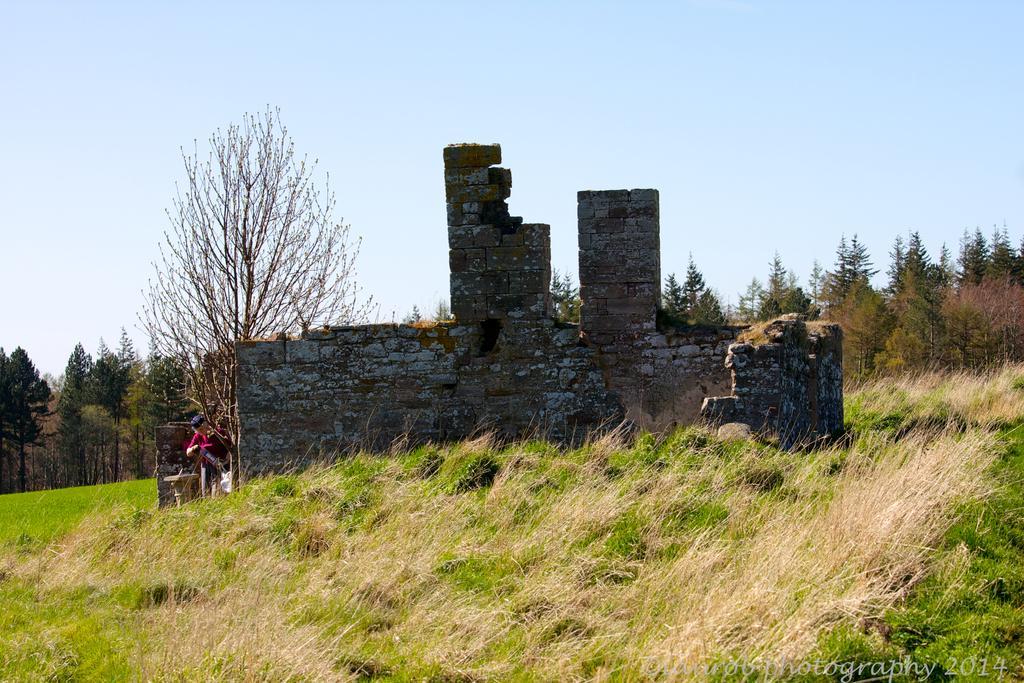Describe this image in one or two sentences. This is the picture of a place where we have a person beside the wall on the grass floor and also we can see plants and trees. 